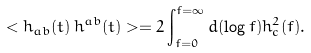Convert formula to latex. <formula><loc_0><loc_0><loc_500><loc_500>< h _ { a b } ( t ) \, h ^ { a b } ( t ) > = 2 \int _ { f = 0 } ^ { f = \infty } d ( \log { f } ) h _ { c } ^ { 2 } ( f ) .</formula> 